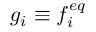Convert formula to latex. <formula><loc_0><loc_0><loc_500><loc_500>g _ { i } \equiv f _ { i } ^ { e q }</formula> 